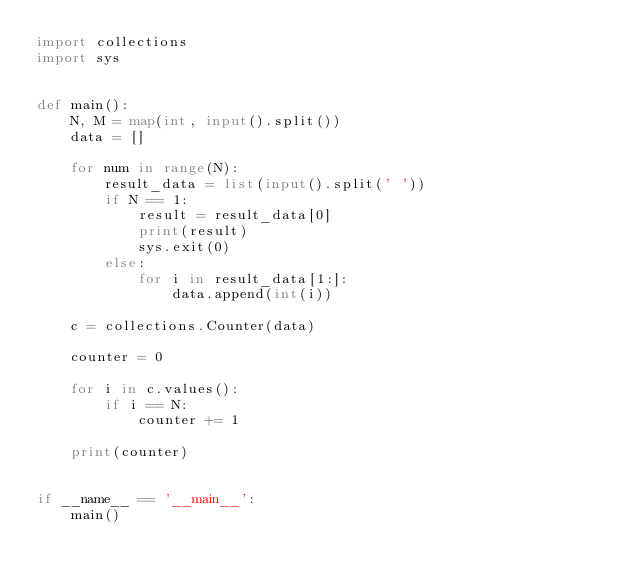Convert code to text. <code><loc_0><loc_0><loc_500><loc_500><_Python_>import collections
import sys


def main():
    N, M = map(int, input().split())
    data = []

    for num in range(N):
        result_data = list(input().split(' '))
        if N == 1:
            result = result_data[0]
            print(result)
            sys.exit(0)
        else:
            for i in result_data[1:]:
                data.append(int(i))

    c = collections.Counter(data)

    counter = 0

    for i in c.values():
        if i == N:
            counter += 1

    print(counter)


if __name__ == '__main__':
    main()</code> 